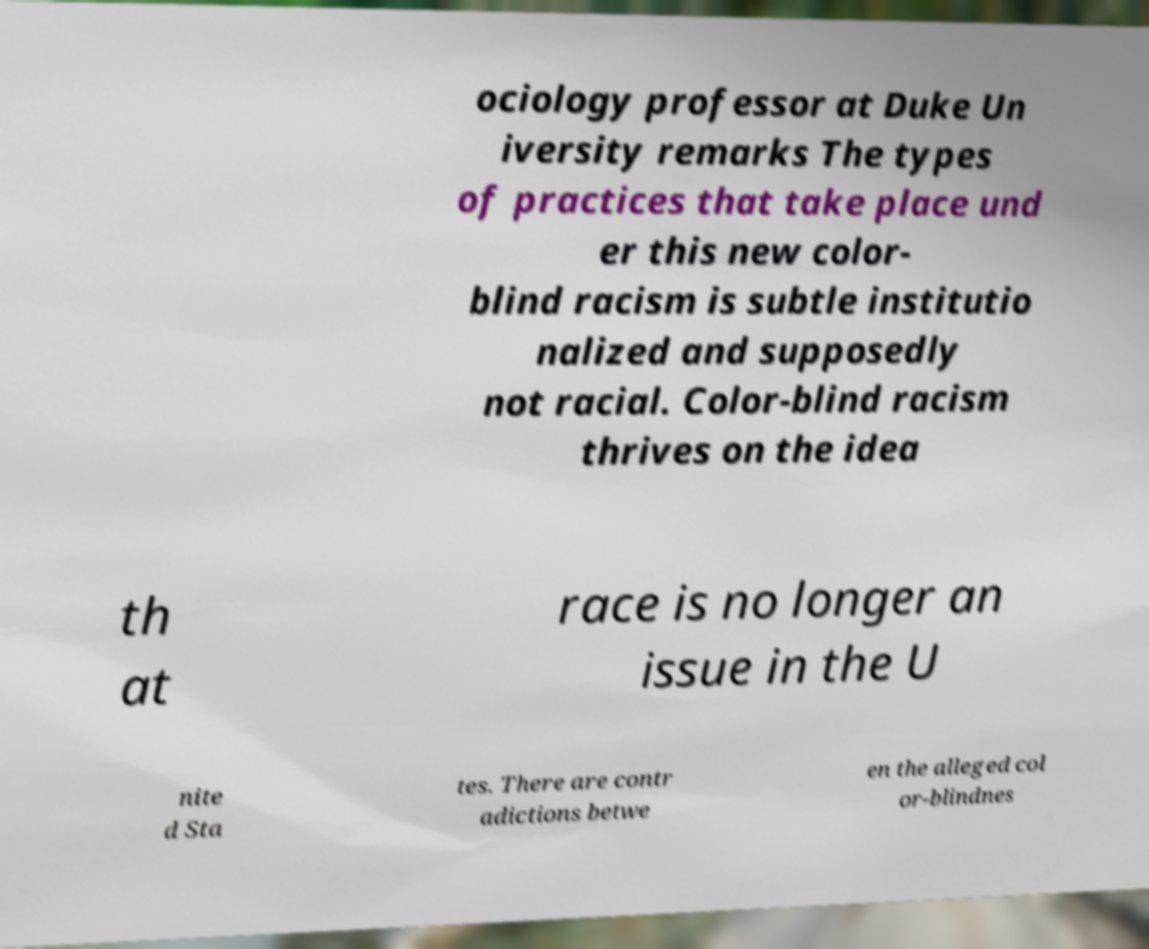Could you assist in decoding the text presented in this image and type it out clearly? ociology professor at Duke Un iversity remarks The types of practices that take place und er this new color- blind racism is subtle institutio nalized and supposedly not racial. Color-blind racism thrives on the idea th at race is no longer an issue in the U nite d Sta tes. There are contr adictions betwe en the alleged col or-blindnes 